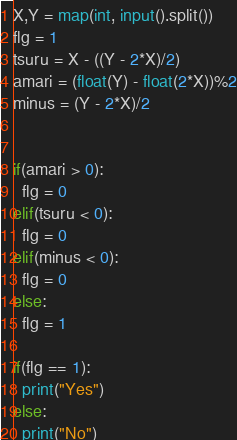Convert code to text. <code><loc_0><loc_0><loc_500><loc_500><_Python_>X,Y = map(int, input().split())
flg = 1
tsuru = X - ((Y - 2*X)/2)
amari = (float(Y) - float(2*X))%2
minus = (Y - 2*X)/2


if(amari > 0):
  flg = 0
elif(tsuru < 0):
  flg = 0
elif(minus < 0):
  flg = 0
else:
  flg = 1

if(flg == 1):
  print("Yes")
else:
  print("No")</code> 